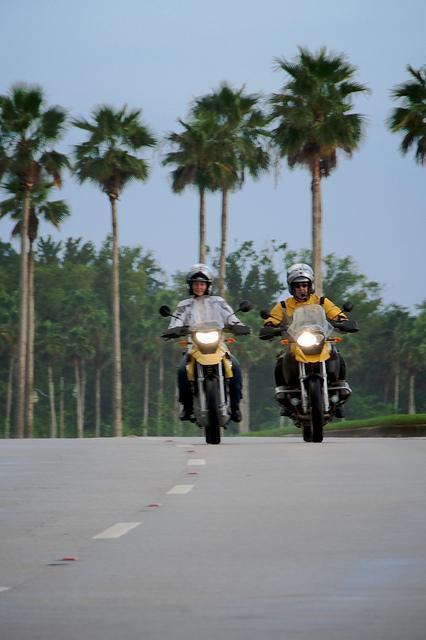What type of vehicle are the men riding?
Make your selection from the four choices given to correctly answer the question.
Options: Train, motorcycle, car, bus. Motorcycle. 